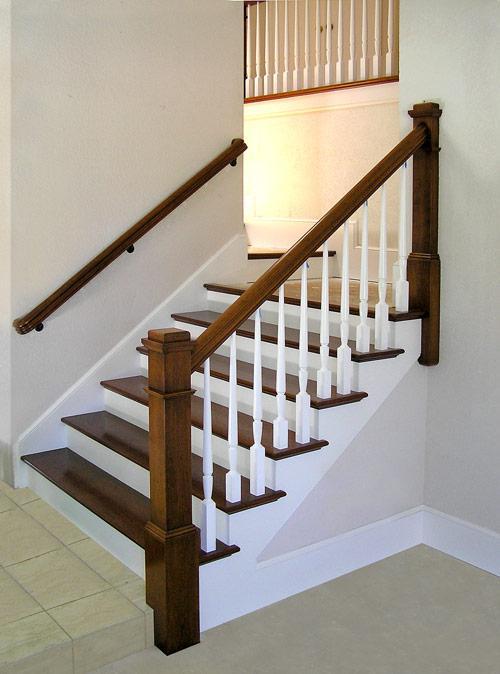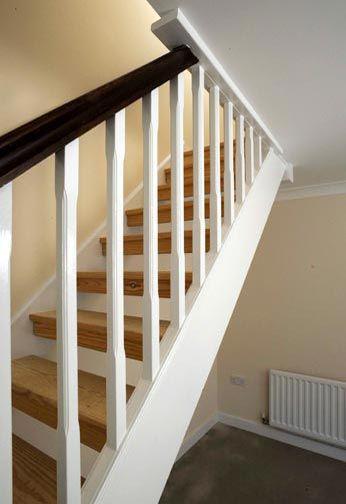The first image is the image on the left, the second image is the image on the right. Analyze the images presented: Is the assertion "The left image shows a staircase that ascends rightward before turning and has black wrought iron rails with scroll shapes." valid? Answer yes or no. No. The first image is the image on the left, the second image is the image on the right. Evaluate the accuracy of this statement regarding the images: "At least one stairway has white side railings.". Is it true? Answer yes or no. Yes. 